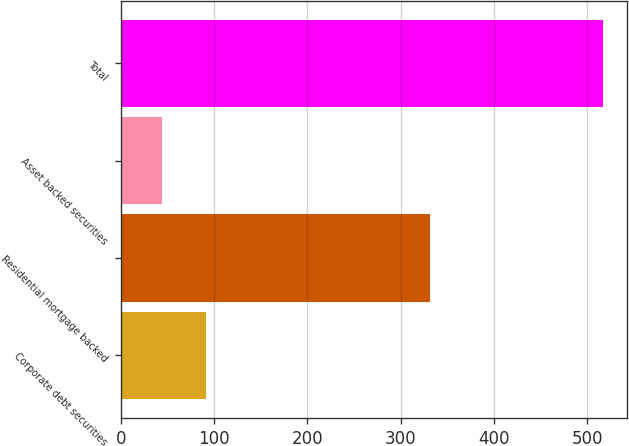Convert chart to OTSL. <chart><loc_0><loc_0><loc_500><loc_500><bar_chart><fcel>Corporate debt securities<fcel>Residential mortgage backed<fcel>Asset backed securities<fcel>Total<nl><fcel>91.3<fcel>331<fcel>44<fcel>517<nl></chart> 